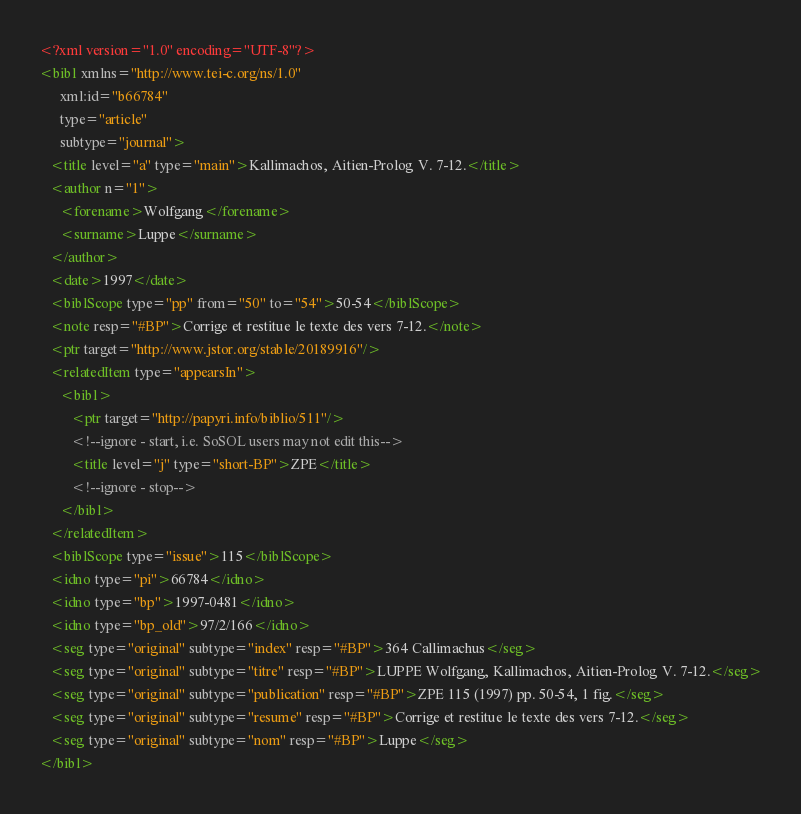<code> <loc_0><loc_0><loc_500><loc_500><_XML_><?xml version="1.0" encoding="UTF-8"?>
<bibl xmlns="http://www.tei-c.org/ns/1.0"
      xml:id="b66784"
      type="article"
      subtype="journal">
   <title level="a" type="main">Kallimachos, Aitien-Prolog V. 7-12.</title>
   <author n="1">
      <forename>Wolfgang</forename>
      <surname>Luppe</surname>
   </author>
   <date>1997</date>
   <biblScope type="pp" from="50" to="54">50-54</biblScope>
   <note resp="#BP">Corrige et restitue le texte des vers 7-12.</note>
   <ptr target="http://www.jstor.org/stable/20189916"/>
   <relatedItem type="appearsIn">
      <bibl>
         <ptr target="http://papyri.info/biblio/511"/>
         <!--ignore - start, i.e. SoSOL users may not edit this-->
         <title level="j" type="short-BP">ZPE</title>
         <!--ignore - stop-->
      </bibl>
   </relatedItem>
   <biblScope type="issue">115</biblScope>
   <idno type="pi">66784</idno>
   <idno type="bp">1997-0481</idno>
   <idno type="bp_old">97/2/166</idno>
   <seg type="original" subtype="index" resp="#BP">364 Callimachus</seg>
   <seg type="original" subtype="titre" resp="#BP">LUPPE Wolfgang, Kallimachos, Aitien-Prolog V. 7-12.</seg>
   <seg type="original" subtype="publication" resp="#BP">ZPE 115 (1997) pp. 50-54, 1 fig.</seg>
   <seg type="original" subtype="resume" resp="#BP">Corrige et restitue le texte des vers 7-12.</seg>
   <seg type="original" subtype="nom" resp="#BP">Luppe</seg>
</bibl>
</code> 